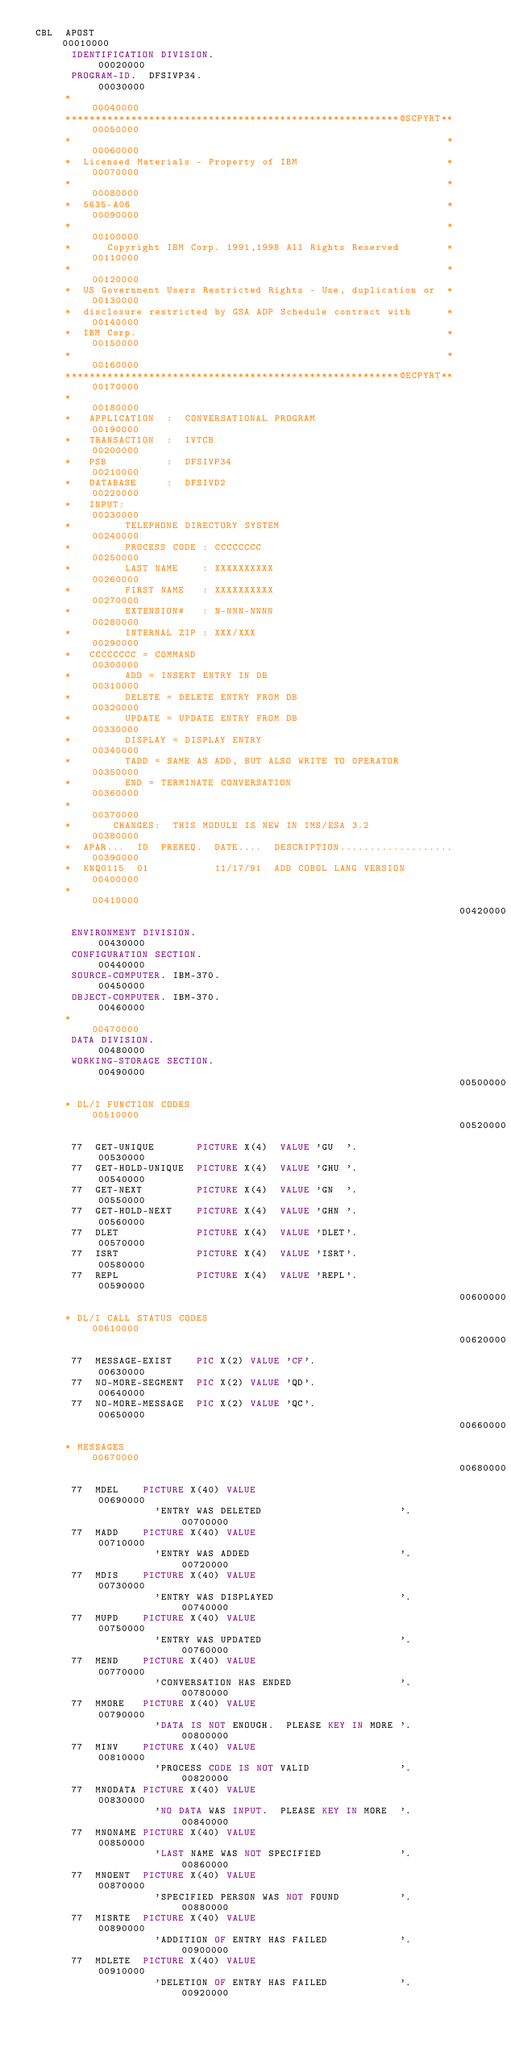<code> <loc_0><loc_0><loc_500><loc_500><_COBOL_> CBL  APOST                                                             00010000
       IDENTIFICATION DIVISION.                                         00020000
       PROGRAM-ID.  DFSIVP34.                                           00030000
      *                                                                 00040000
      ********************************************************@SCPYRT** 00050000
      *                                                               * 00060000
      *  Licensed Materials - Property of IBM                         * 00070000
      *                                                               * 00080000
      *  5635-A06                                                     * 00090000
      *                                                               * 00100000
      *      Copyright IBM Corp. 1991,1998 All Rights Reserved        * 00110000
      *                                                               * 00120000
      *  US Government Users Restricted Rights - Use, duplication or  * 00130000
      *  disclosure restricted by GSA ADP Schedule contract with      * 00140000
      *  IBM Corp.                                                    * 00150000
      *                                                               * 00160000
      ********************************************************@ECPYRT** 00170000
      *                                                                 00180000
      *   APPLICATION  :  CONVERSATIONAL PROGRAM                        00190000
      *   TRANSACTION  :  IVTCB                                         00200000
      *   PSB          :  DFSIVP34                                      00210000
      *   DATABASE     :  DFSIVD2                                       00220000
      *   INPUT:                                                        00230000
      *         TELEPHONE DIRECTORY SYSTEM                              00240000
      *         PROCESS CODE : CCCCCCCC                                 00250000
      *         LAST NAME    : XXXXXXXXXX                               00260000
      *         FIRST NAME   : XXXXXXXXXX                               00270000
      *         EXTENSION#   : N-NNN-NNNN                               00280000
      *         INTERNAL ZIP : XXX/XXX                                  00290000
      *   CCCCCCCC = COMMAND                                            00300000
      *         ADD = INSERT ENTRY IN DB                                00310000
      *         DELETE = DELETE ENTRY FROM DB                           00320000
      *         UPDATE = UPDATE ENTRY FROM DB                           00330000
      *         DISPLAY = DISPLAY ENTRY                                 00340000
      *         TADD = SAME AS ADD, BUT ALSO WRITE TO OPERATOR          00350000
      *         END = TERMINATE CONVERSATION                            00360000
      *                                                                 00370000
      *       CHANGES:  THIS MODULE IS NEW IN IMS/ESA 3.2               00380000
      *  APAR...  ID  PREREQ.  DATE....  DESCRIPTION................... 00390000
      *  KNQ0115  01           11/17/91  ADD COBOL LANG VERSION         00400000
      *                                                                 00410000
                                                                        00420000
       ENVIRONMENT DIVISION.                                            00430000
       CONFIGURATION SECTION.                                           00440000
       SOURCE-COMPUTER. IBM-370.                                        00450000
       OBJECT-COMPUTER. IBM-370.                                        00460000
      *                                                                 00470000
       DATA DIVISION.                                                   00480000
       WORKING-STORAGE SECTION.                                         00490000
                                                                        00500000
      * DL/I FUNCTION CODES                                             00510000
                                                                        00520000
       77  GET-UNIQUE       PICTURE X(4)  VALUE 'GU  '.                 00530000
       77  GET-HOLD-UNIQUE  PICTURE X(4)  VALUE 'GHU '.                 00540000
       77  GET-NEXT         PICTURE X(4)  VALUE 'GN  '.                 00550000
       77  GET-HOLD-NEXT    PICTURE X(4)  VALUE 'GHN '.                 00560000
       77  DLET             PICTURE X(4)  VALUE 'DLET'.                 00570000
       77  ISRT             PICTURE X(4)  VALUE 'ISRT'.                 00580000
       77  REPL             PICTURE X(4)  VALUE 'REPL'.                 00590000
                                                                        00600000
      * DL/I CALL STATUS CODES                                          00610000
                                                                        00620000
       77  MESSAGE-EXIST    PIC X(2) VALUE 'CF'.                        00630000
       77  NO-MORE-SEGMENT  PIC X(2) VALUE 'QD'.                        00640000
       77  NO-MORE-MESSAGE  PIC X(2) VALUE 'QC'.                        00650000
                                                                        00660000
      * MESSAGES                                                        00670000
                                                                        00680000
       77  MDEL    PICTURE X(40) VALUE                                  00690000
                     'ENTRY WAS DELETED                       '.        00700000
       77  MADD    PICTURE X(40) VALUE                                  00710000
                     'ENTRY WAS ADDED                         '.        00720000
       77  MDIS    PICTURE X(40) VALUE                                  00730000
                     'ENTRY WAS DISPLAYED                     '.        00740000
       77  MUPD    PICTURE X(40) VALUE                                  00750000
                     'ENTRY WAS UPDATED                       '.        00760000
       77  MEND    PICTURE X(40) VALUE                                  00770000
                     'CONVERSATION HAS ENDED                  '.        00780000
       77  MMORE   PICTURE X(40) VALUE                                  00790000
                     'DATA IS NOT ENOUGH.  PLEASE KEY IN MORE '.        00800000
       77  MINV    PICTURE X(40) VALUE                                  00810000
                     'PROCESS CODE IS NOT VALID               '.        00820000
       77  MNODATA PICTURE X(40) VALUE                                  00830000
                     'NO DATA WAS INPUT.  PLEASE KEY IN MORE  '.        00840000
       77  MNONAME PICTURE X(40) VALUE                                  00850000
                     'LAST NAME WAS NOT SPECIFIED             '.        00860000
       77  MNOENT  PICTURE X(40) VALUE                                  00870000
                     'SPECIFIED PERSON WAS NOT FOUND          '.        00880000
       77  MISRTE  PICTURE X(40) VALUE                                  00890000
                     'ADDITION OF ENTRY HAS FAILED            '.        00900000
       77  MDLETE  PICTURE X(40) VALUE                                  00910000
                     'DELETION OF ENTRY HAS FAILED            '.        00920000</code> 